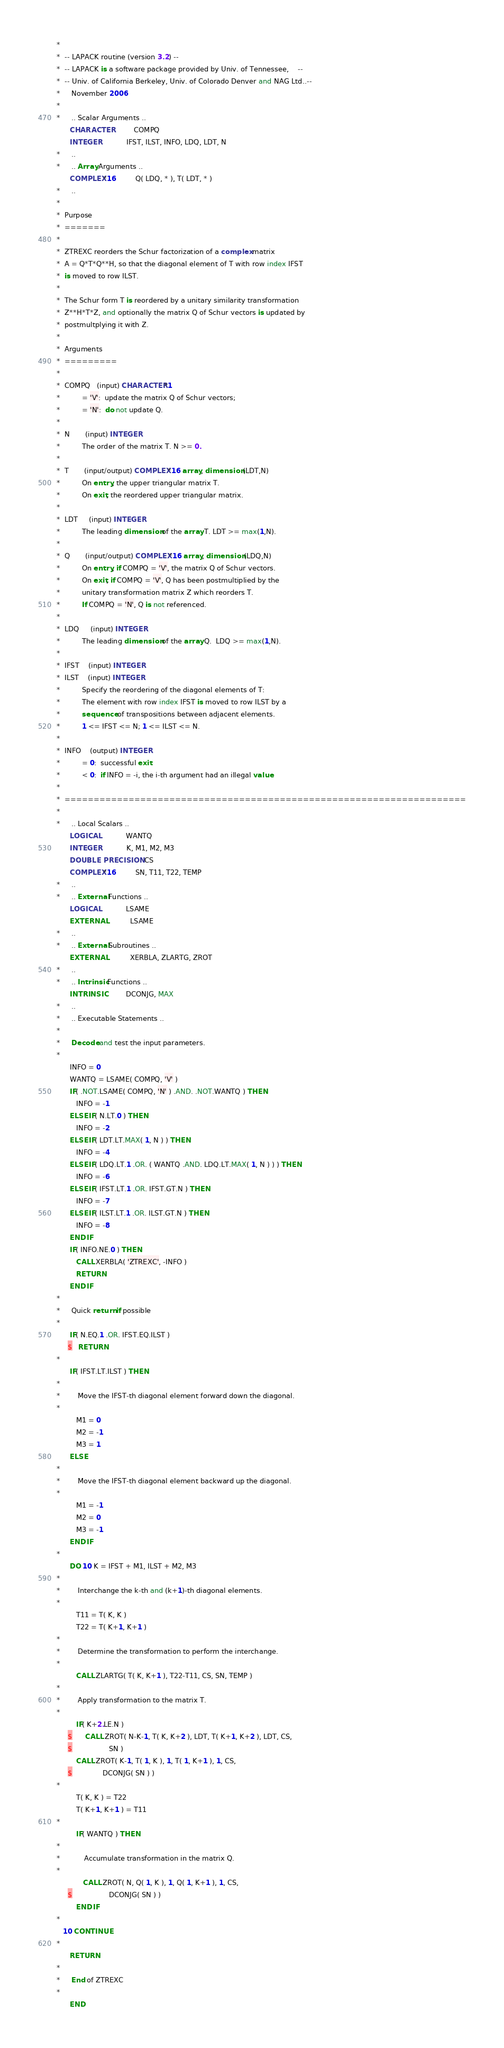Convert code to text. <code><loc_0><loc_0><loc_500><loc_500><_FORTRAN_>*
*  -- LAPACK routine (version 3.2) --
*  -- LAPACK is a software package provided by Univ. of Tennessee,    --
*  -- Univ. of California Berkeley, Univ. of Colorado Denver and NAG Ltd..--
*     November 2006
*
*     .. Scalar Arguments ..
      CHARACTER          COMPQ
      INTEGER            IFST, ILST, INFO, LDQ, LDT, N
*     ..
*     .. Array Arguments ..
      COMPLEX*16         Q( LDQ, * ), T( LDT, * )
*     ..
*
*  Purpose
*  =======
*
*  ZTREXC reorders the Schur factorization of a complex matrix
*  A = Q*T*Q**H, so that the diagonal element of T with row index IFST
*  is moved to row ILST.
*
*  The Schur form T is reordered by a unitary similarity transformation
*  Z**H*T*Z, and optionally the matrix Q of Schur vectors is updated by
*  postmultplying it with Z.
*
*  Arguments
*  =========
*
*  COMPQ   (input) CHARACTER*1
*          = 'V':  update the matrix Q of Schur vectors;
*          = 'N':  do not update Q.
*
*  N       (input) INTEGER
*          The order of the matrix T. N >= 0.
*
*  T       (input/output) COMPLEX*16 array, dimension (LDT,N)
*          On entry, the upper triangular matrix T.
*          On exit, the reordered upper triangular matrix.
*
*  LDT     (input) INTEGER
*          The leading dimension of the array T. LDT >= max(1,N).
*
*  Q       (input/output) COMPLEX*16 array, dimension (LDQ,N)
*          On entry, if COMPQ = 'V', the matrix Q of Schur vectors.
*          On exit, if COMPQ = 'V', Q has been postmultiplied by the
*          unitary transformation matrix Z which reorders T.
*          If COMPQ = 'N', Q is not referenced.
*
*  LDQ     (input) INTEGER
*          The leading dimension of the array Q.  LDQ >= max(1,N).
*
*  IFST    (input) INTEGER
*  ILST    (input) INTEGER
*          Specify the reordering of the diagonal elements of T:
*          The element with row index IFST is moved to row ILST by a
*          sequence of transpositions between adjacent elements.
*          1 <= IFST <= N; 1 <= ILST <= N.
*
*  INFO    (output) INTEGER
*          = 0:  successful exit
*          < 0:  if INFO = -i, the i-th argument had an illegal value
*
*  =====================================================================
*
*     .. Local Scalars ..
      LOGICAL            WANTQ
      INTEGER            K, M1, M2, M3
      DOUBLE PRECISION   CS
      COMPLEX*16         SN, T11, T22, TEMP
*     ..
*     .. External Functions ..
      LOGICAL            LSAME
      EXTERNAL           LSAME
*     ..
*     .. External Subroutines ..
      EXTERNAL           XERBLA, ZLARTG, ZROT
*     ..
*     .. Intrinsic Functions ..
      INTRINSIC          DCONJG, MAX
*     ..
*     .. Executable Statements ..
*
*     Decode and test the input parameters.
*
      INFO = 0
      WANTQ = LSAME( COMPQ, 'V' )
      IF( .NOT.LSAME( COMPQ, 'N' ) .AND. .NOT.WANTQ ) THEN
         INFO = -1
      ELSE IF( N.LT.0 ) THEN
         INFO = -2
      ELSE IF( LDT.LT.MAX( 1, N ) ) THEN
         INFO = -4
      ELSE IF( LDQ.LT.1 .OR. ( WANTQ .AND. LDQ.LT.MAX( 1, N ) ) ) THEN
         INFO = -6
      ELSE IF( IFST.LT.1 .OR. IFST.GT.N ) THEN
         INFO = -7
      ELSE IF( ILST.LT.1 .OR. ILST.GT.N ) THEN
         INFO = -8
      END IF
      IF( INFO.NE.0 ) THEN
         CALL XERBLA( 'ZTREXC', -INFO )
         RETURN
      END IF
*
*     Quick return if possible
*
      IF( N.EQ.1 .OR. IFST.EQ.ILST )
     $   RETURN
*
      IF( IFST.LT.ILST ) THEN
*
*        Move the IFST-th diagonal element forward down the diagonal.
*
         M1 = 0
         M2 = -1
         M3 = 1
      ELSE
*
*        Move the IFST-th diagonal element backward up the diagonal.
*
         M1 = -1
         M2 = 0
         M3 = -1
      END IF
*
      DO 10 K = IFST + M1, ILST + M2, M3
*
*        Interchange the k-th and (k+1)-th diagonal elements.
*
         T11 = T( K, K )
         T22 = T( K+1, K+1 )
*
*        Determine the transformation to perform the interchange.
*
         CALL ZLARTG( T( K, K+1 ), T22-T11, CS, SN, TEMP )
*
*        Apply transformation to the matrix T.
*
         IF( K+2.LE.N )
     $      CALL ZROT( N-K-1, T( K, K+2 ), LDT, T( K+1, K+2 ), LDT, CS,
     $                 SN )
         CALL ZROT( K-1, T( 1, K ), 1, T( 1, K+1 ), 1, CS,
     $              DCONJG( SN ) )
*
         T( K, K ) = T22
         T( K+1, K+1 ) = T11
*
         IF( WANTQ ) THEN
*
*           Accumulate transformation in the matrix Q.
*
            CALL ZROT( N, Q( 1, K ), 1, Q( 1, K+1 ), 1, CS,
     $                 DCONJG( SN ) )
         END IF
*
   10 CONTINUE
*
      RETURN
*
*     End of ZTREXC
*
      END
</code> 